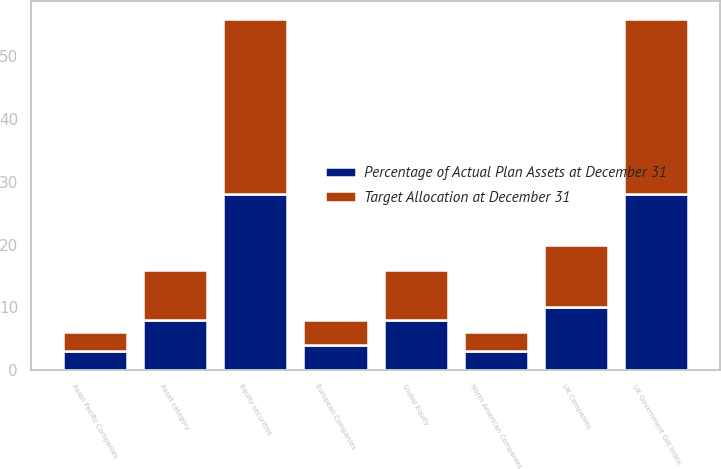<chart> <loc_0><loc_0><loc_500><loc_500><stacked_bar_chart><ecel><fcel>Asset category<fcel>North American Companies<fcel>UK Companies<fcel>European Companies<fcel>Asian Pacific Companies<fcel>Global Equity<fcel>Equity securities<fcel>UK Government Gilt Index<nl><fcel>Target Allocation at December 31<fcel>8<fcel>3<fcel>10<fcel>4<fcel>3<fcel>8<fcel>28<fcel>28<nl><fcel>Percentage of Actual Plan Assets at December 31<fcel>8<fcel>3<fcel>10<fcel>4<fcel>3<fcel>8<fcel>28<fcel>28<nl></chart> 